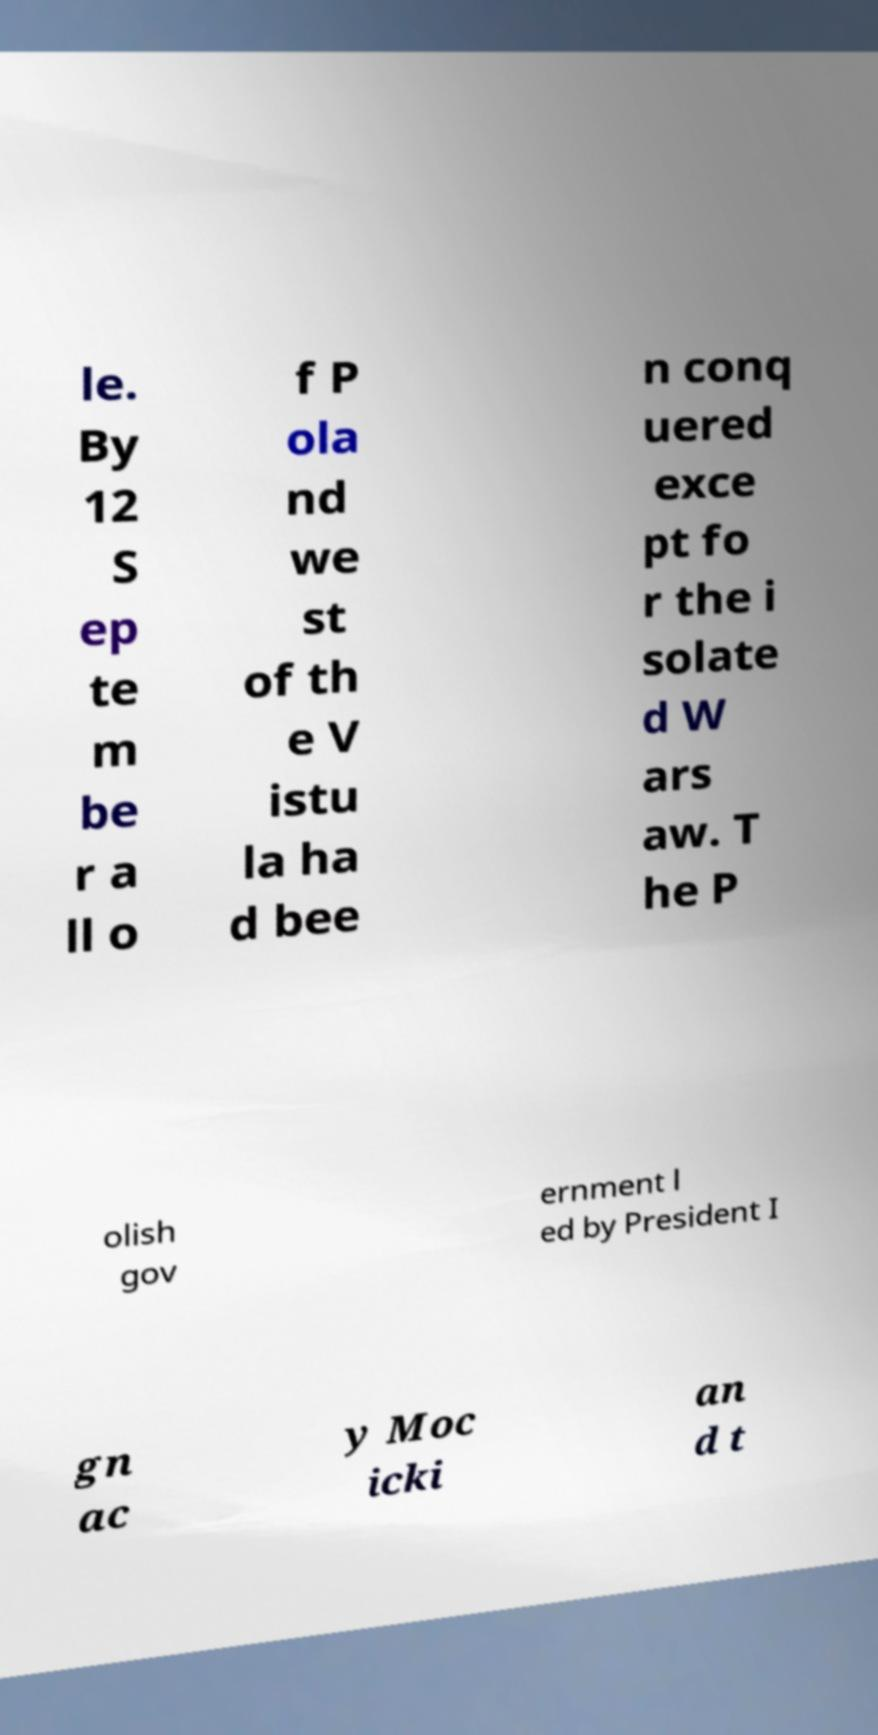Could you assist in decoding the text presented in this image and type it out clearly? le. By 12 S ep te m be r a ll o f P ola nd we st of th e V istu la ha d bee n conq uered exce pt fo r the i solate d W ars aw. T he P olish gov ernment l ed by President I gn ac y Moc icki an d t 